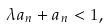Convert formula to latex. <formula><loc_0><loc_0><loc_500><loc_500>\lambda a _ { n } + a _ { n } < 1 ,</formula> 